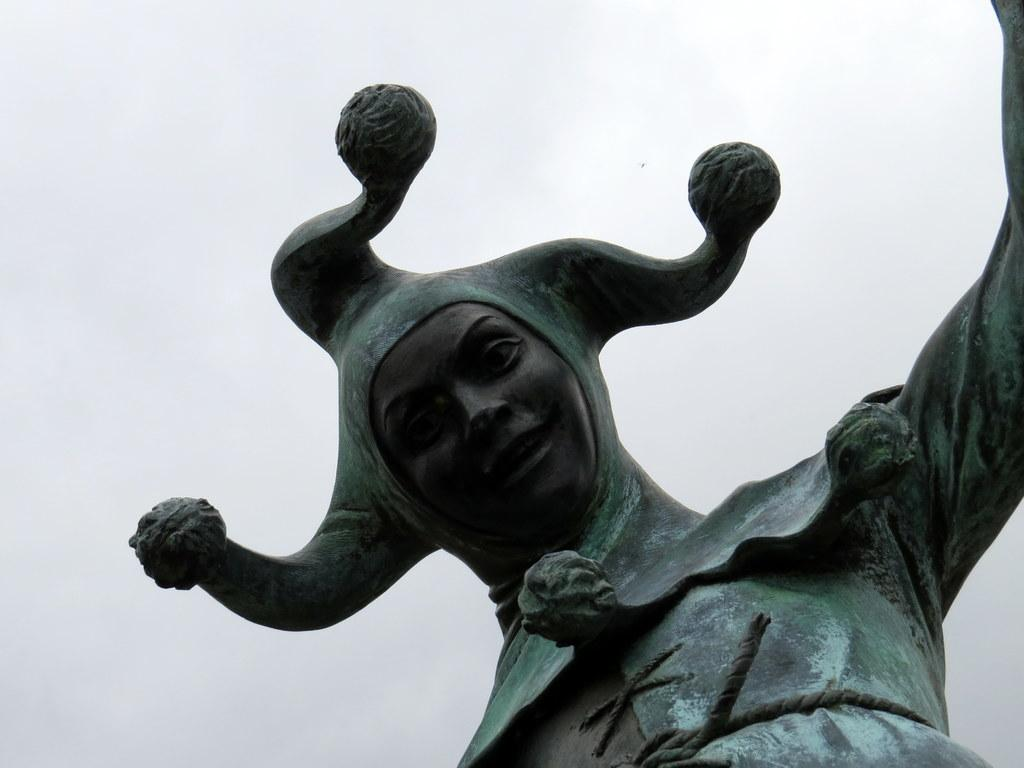What is the main subject of the image? There is a sculpture in the image. What is the best route to take to avoid the slippery dirt in the image? There is no mention of dirt or a slippery surface in the image; it only features a sculpture. 